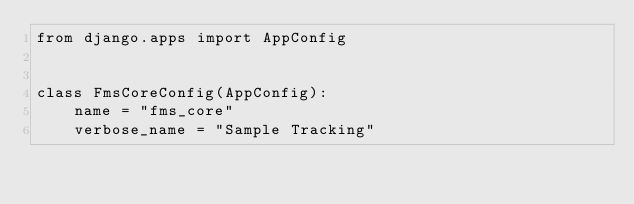<code> <loc_0><loc_0><loc_500><loc_500><_Python_>from django.apps import AppConfig


class FmsCoreConfig(AppConfig):
    name = "fms_core"
    verbose_name = "Sample Tracking"
</code> 